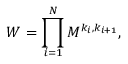<formula> <loc_0><loc_0><loc_500><loc_500>W = \prod _ { i = 1 } ^ { N } M ^ { k _ { i } , k _ { i + 1 } } ,</formula> 